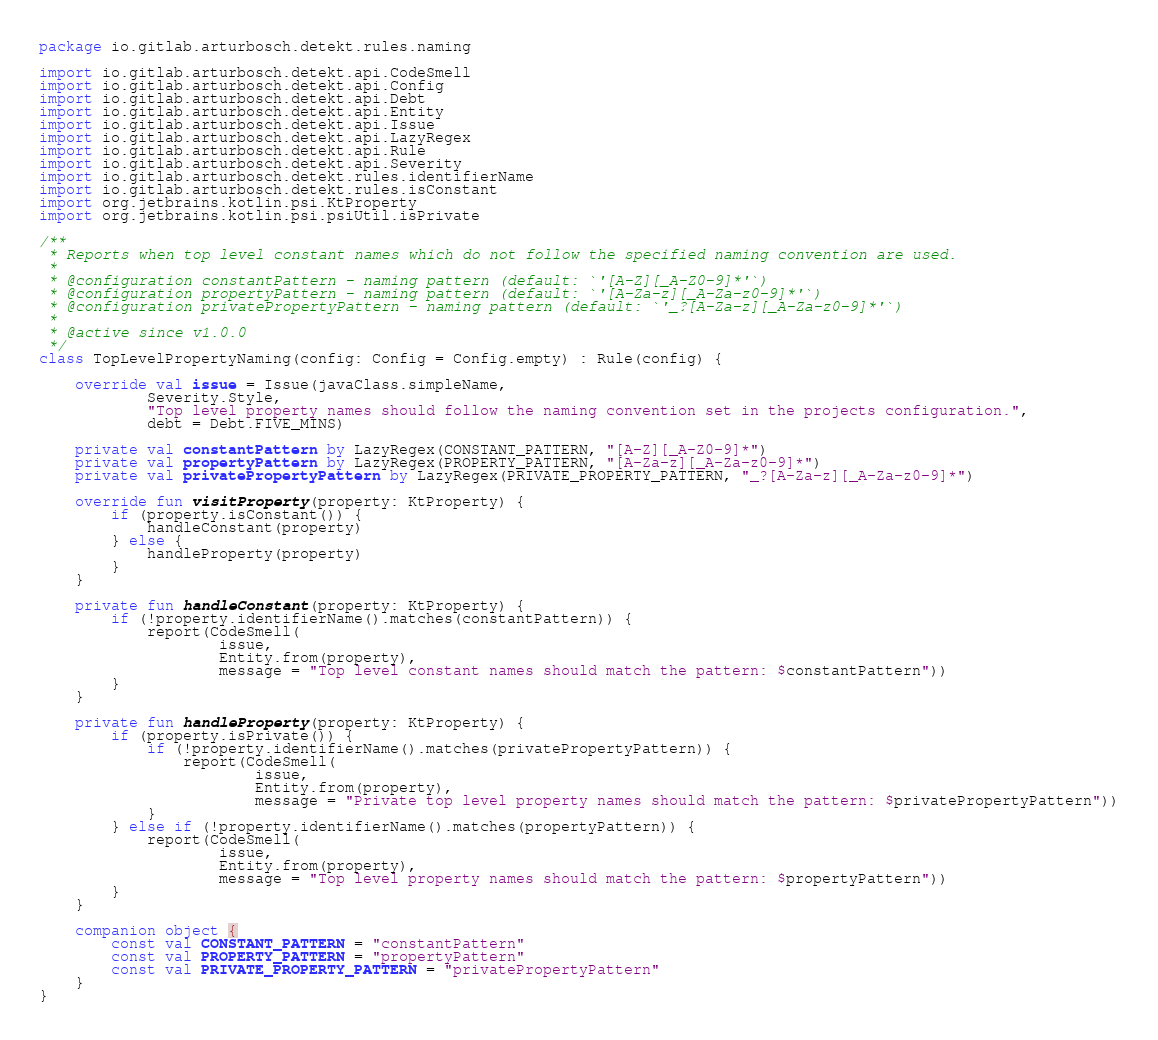<code> <loc_0><loc_0><loc_500><loc_500><_Kotlin_>package io.gitlab.arturbosch.detekt.rules.naming

import io.gitlab.arturbosch.detekt.api.CodeSmell
import io.gitlab.arturbosch.detekt.api.Config
import io.gitlab.arturbosch.detekt.api.Debt
import io.gitlab.arturbosch.detekt.api.Entity
import io.gitlab.arturbosch.detekt.api.Issue
import io.gitlab.arturbosch.detekt.api.LazyRegex
import io.gitlab.arturbosch.detekt.api.Rule
import io.gitlab.arturbosch.detekt.api.Severity
import io.gitlab.arturbosch.detekt.rules.identifierName
import io.gitlab.arturbosch.detekt.rules.isConstant
import org.jetbrains.kotlin.psi.KtProperty
import org.jetbrains.kotlin.psi.psiUtil.isPrivate

/**
 * Reports when top level constant names which do not follow the specified naming convention are used.
 *
 * @configuration constantPattern - naming pattern (default: `'[A-Z][_A-Z0-9]*'`)
 * @configuration propertyPattern - naming pattern (default: `'[A-Za-z][_A-Za-z0-9]*'`)
 * @configuration privatePropertyPattern - naming pattern (default: `'_?[A-Za-z][_A-Za-z0-9]*'`)
 *
 * @active since v1.0.0
 */
class TopLevelPropertyNaming(config: Config = Config.empty) : Rule(config) {

    override val issue = Issue(javaClass.simpleName,
            Severity.Style,
            "Top level property names should follow the naming convention set in the projects configuration.",
            debt = Debt.FIVE_MINS)

    private val constantPattern by LazyRegex(CONSTANT_PATTERN, "[A-Z][_A-Z0-9]*")
    private val propertyPattern by LazyRegex(PROPERTY_PATTERN, "[A-Za-z][_A-Za-z0-9]*")
    private val privatePropertyPattern by LazyRegex(PRIVATE_PROPERTY_PATTERN, "_?[A-Za-z][_A-Za-z0-9]*")

    override fun visitProperty(property: KtProperty) {
        if (property.isConstant()) {
            handleConstant(property)
        } else {
            handleProperty(property)
        }
    }

    private fun handleConstant(property: KtProperty) {
        if (!property.identifierName().matches(constantPattern)) {
            report(CodeSmell(
                    issue,
                    Entity.from(property),
                    message = "Top level constant names should match the pattern: $constantPattern"))
        }
    }

    private fun handleProperty(property: KtProperty) {
        if (property.isPrivate()) {
            if (!property.identifierName().matches(privatePropertyPattern)) {
                report(CodeSmell(
                        issue,
                        Entity.from(property),
                        message = "Private top level property names should match the pattern: $privatePropertyPattern"))
            }
        } else if (!property.identifierName().matches(propertyPattern)) {
            report(CodeSmell(
                    issue,
                    Entity.from(property),
                    message = "Top level property names should match the pattern: $propertyPattern"))
        }
    }

    companion object {
        const val CONSTANT_PATTERN = "constantPattern"
        const val PROPERTY_PATTERN = "propertyPattern"
        const val PRIVATE_PROPERTY_PATTERN = "privatePropertyPattern"
    }
}
</code> 